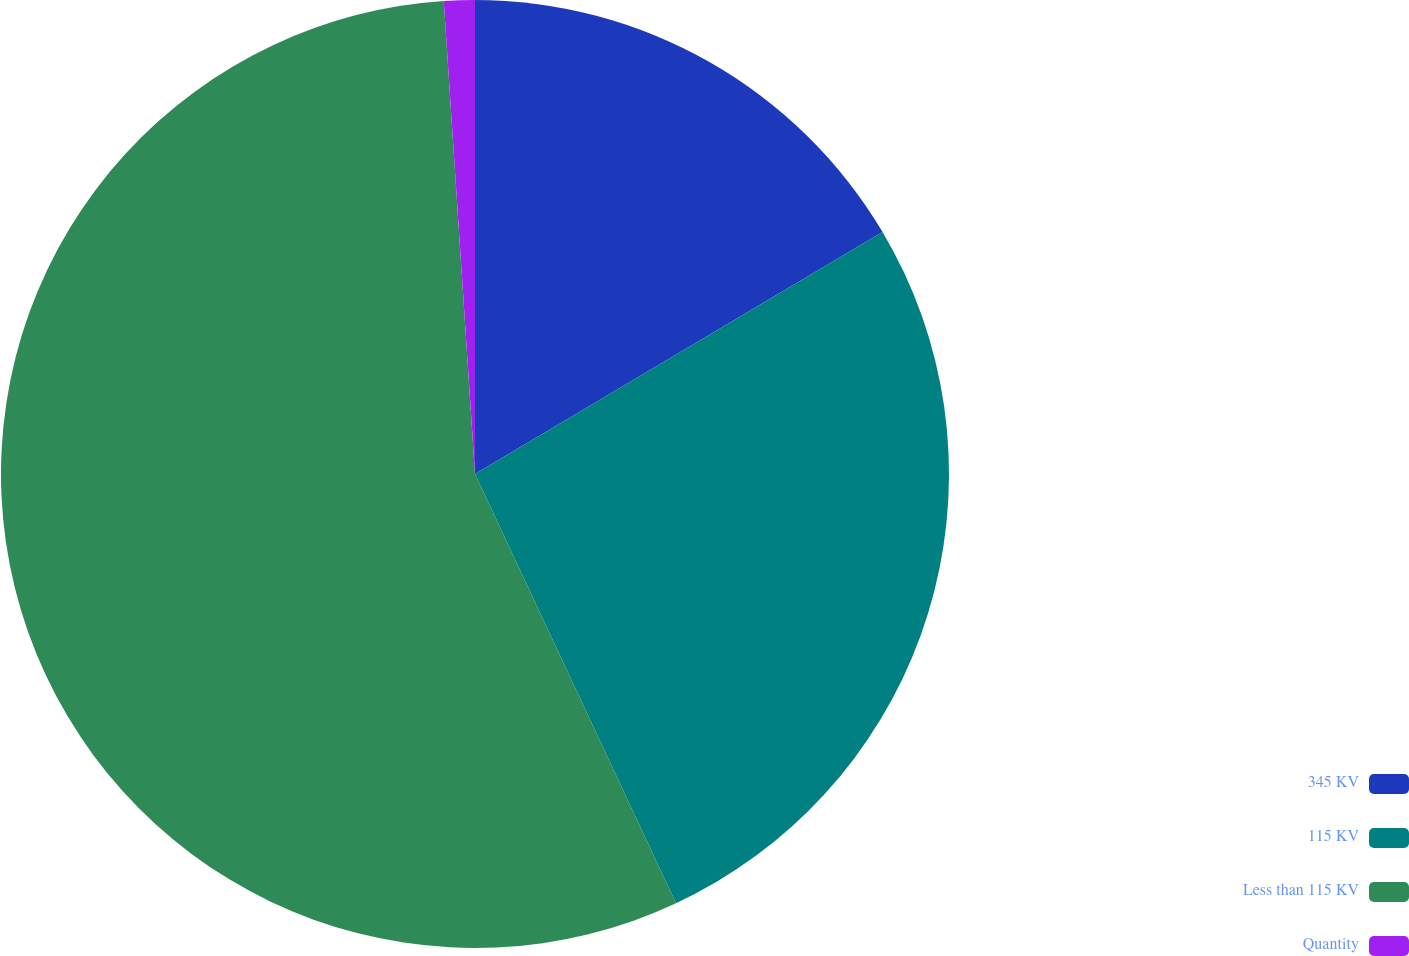Convert chart. <chart><loc_0><loc_0><loc_500><loc_500><pie_chart><fcel>345 KV<fcel>115 KV<fcel>Less than 115 KV<fcel>Quantity<nl><fcel>16.47%<fcel>26.56%<fcel>55.92%<fcel>1.05%<nl></chart> 